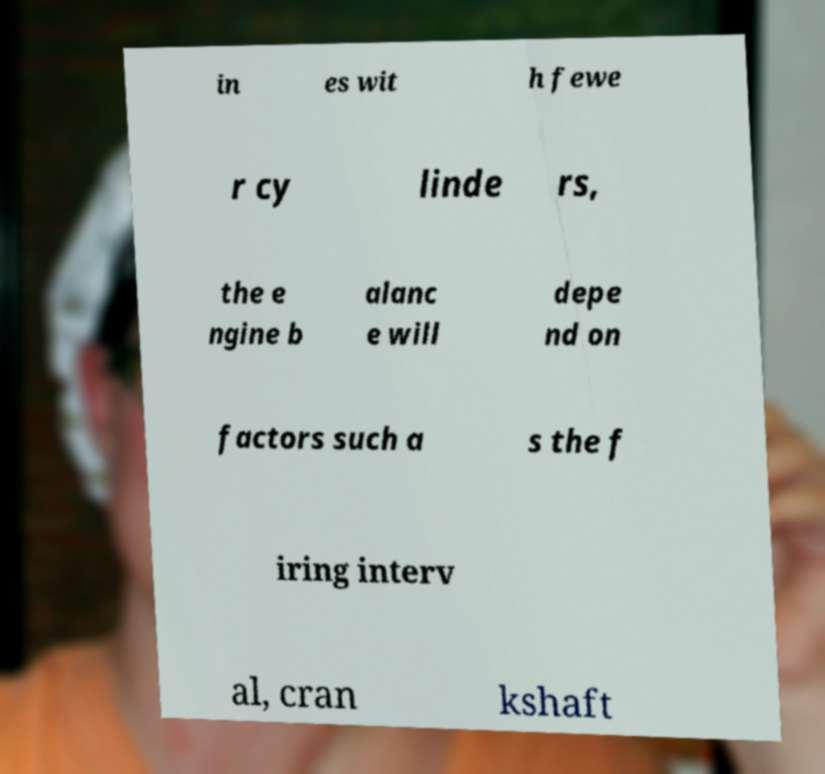What messages or text are displayed in this image? I need them in a readable, typed format. in es wit h fewe r cy linde rs, the e ngine b alanc e will depe nd on factors such a s the f iring interv al, cran kshaft 